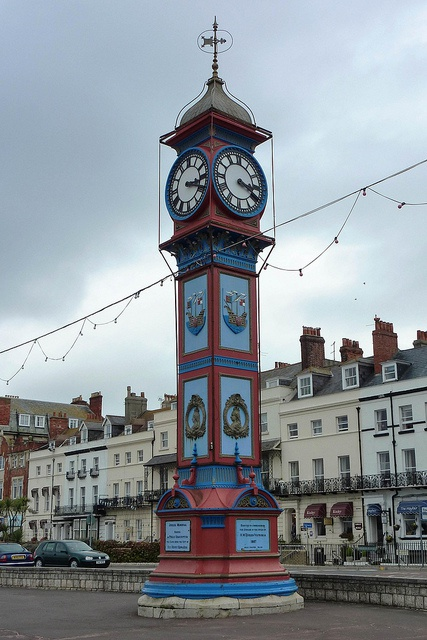Describe the objects in this image and their specific colors. I can see clock in lavender, darkgray, black, gray, and navy tones, clock in lavender, black, darkgray, gray, and navy tones, car in lavender, black, gray, and purple tones, and car in lavender, black, and gray tones in this image. 